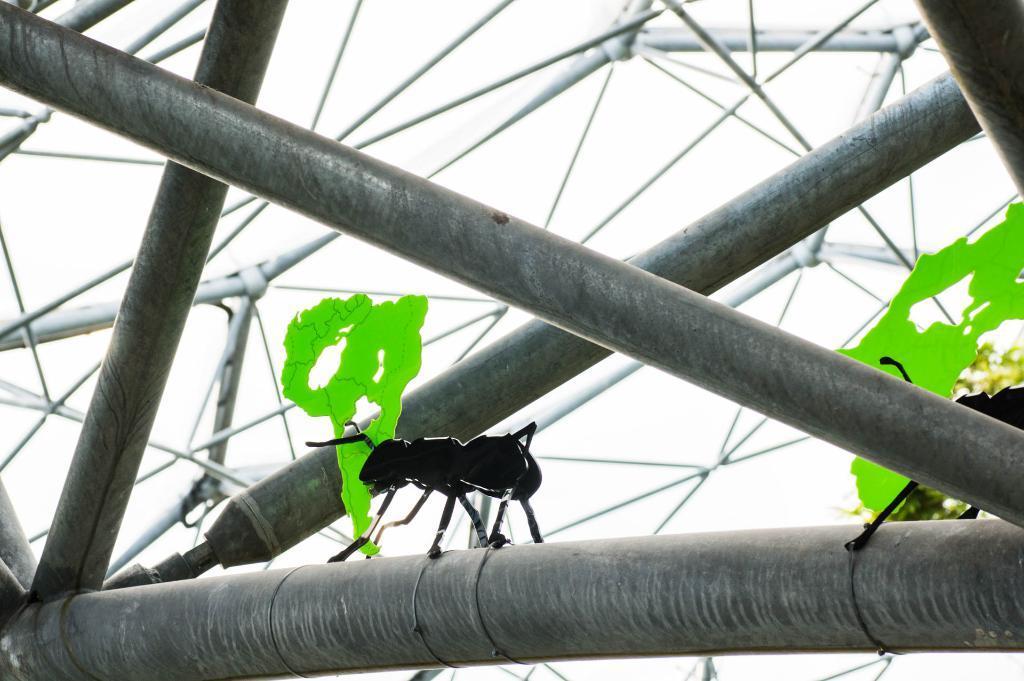How would you summarize this image in a sentence or two? In this picture we can see rods and on a rod we can see two black ants. 